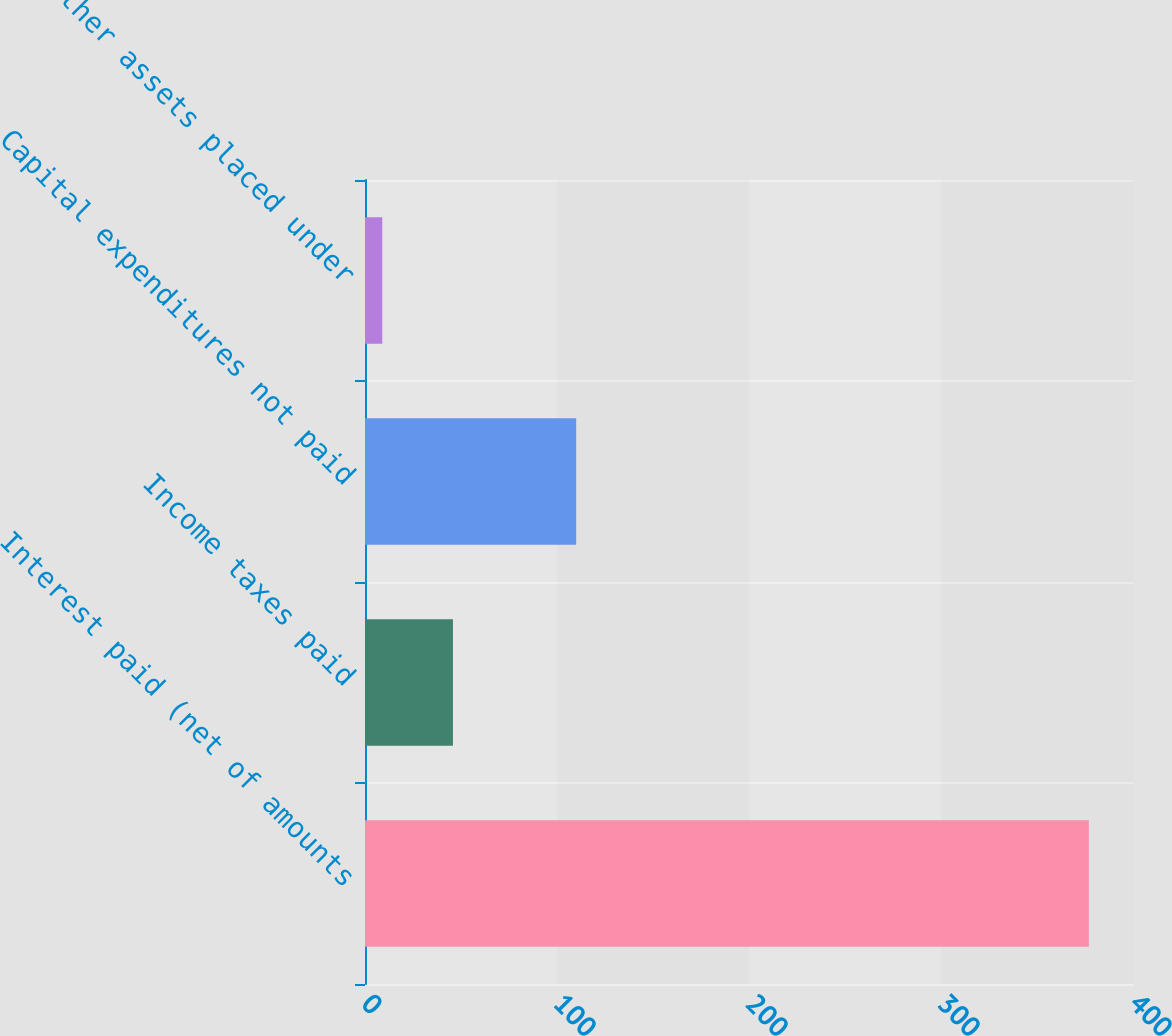<chart> <loc_0><loc_0><loc_500><loc_500><bar_chart><fcel>Interest paid (net of amounts<fcel>Income taxes paid<fcel>Capital expenditures not paid<fcel>Other assets placed under<nl><fcel>377<fcel>45.8<fcel>110<fcel>9<nl></chart> 